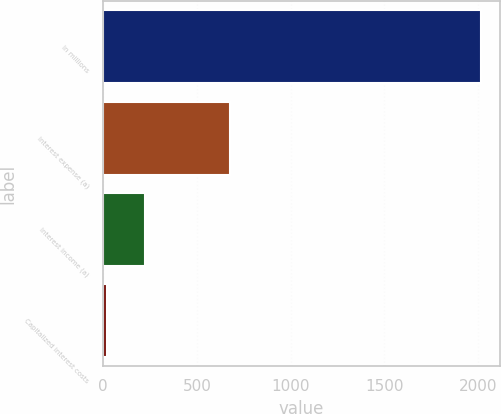<chart> <loc_0><loc_0><loc_500><loc_500><bar_chart><fcel>In millions<fcel>Interest expense (a)<fcel>Interest income (a)<fcel>Capitalized interest costs<nl><fcel>2014<fcel>677<fcel>222.1<fcel>23<nl></chart> 